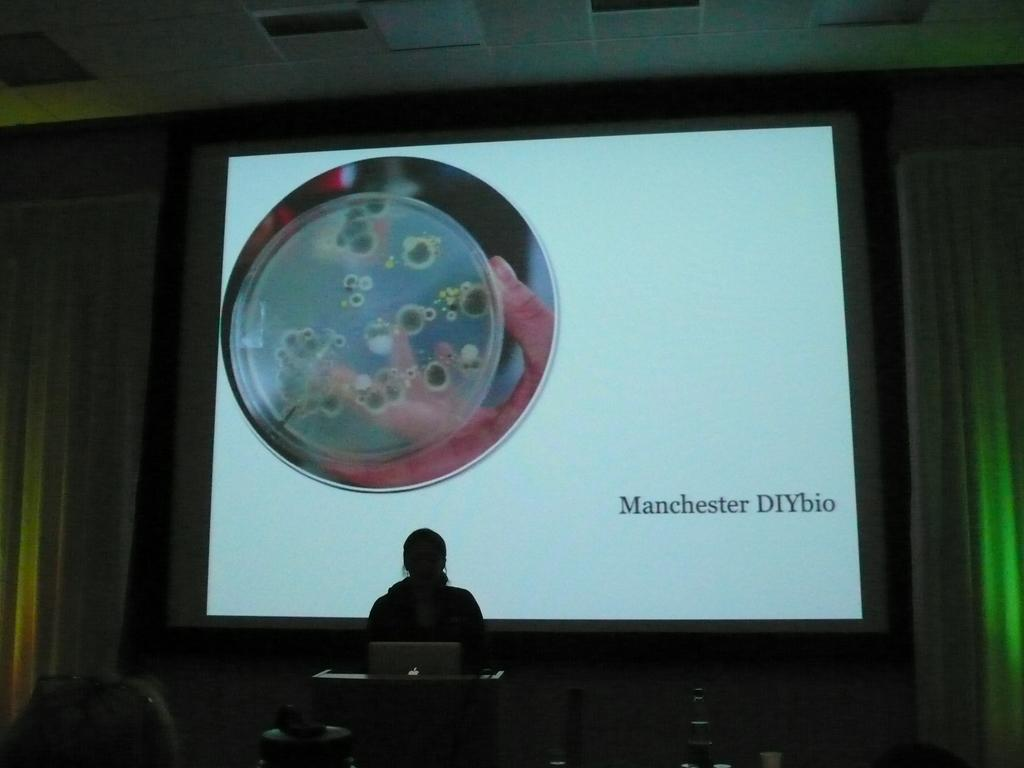<image>
Describe the image concisely. A dark room with a woman speaker in front of a screen that reads Manchester DIYbio on the lower right hand side is pictured. 